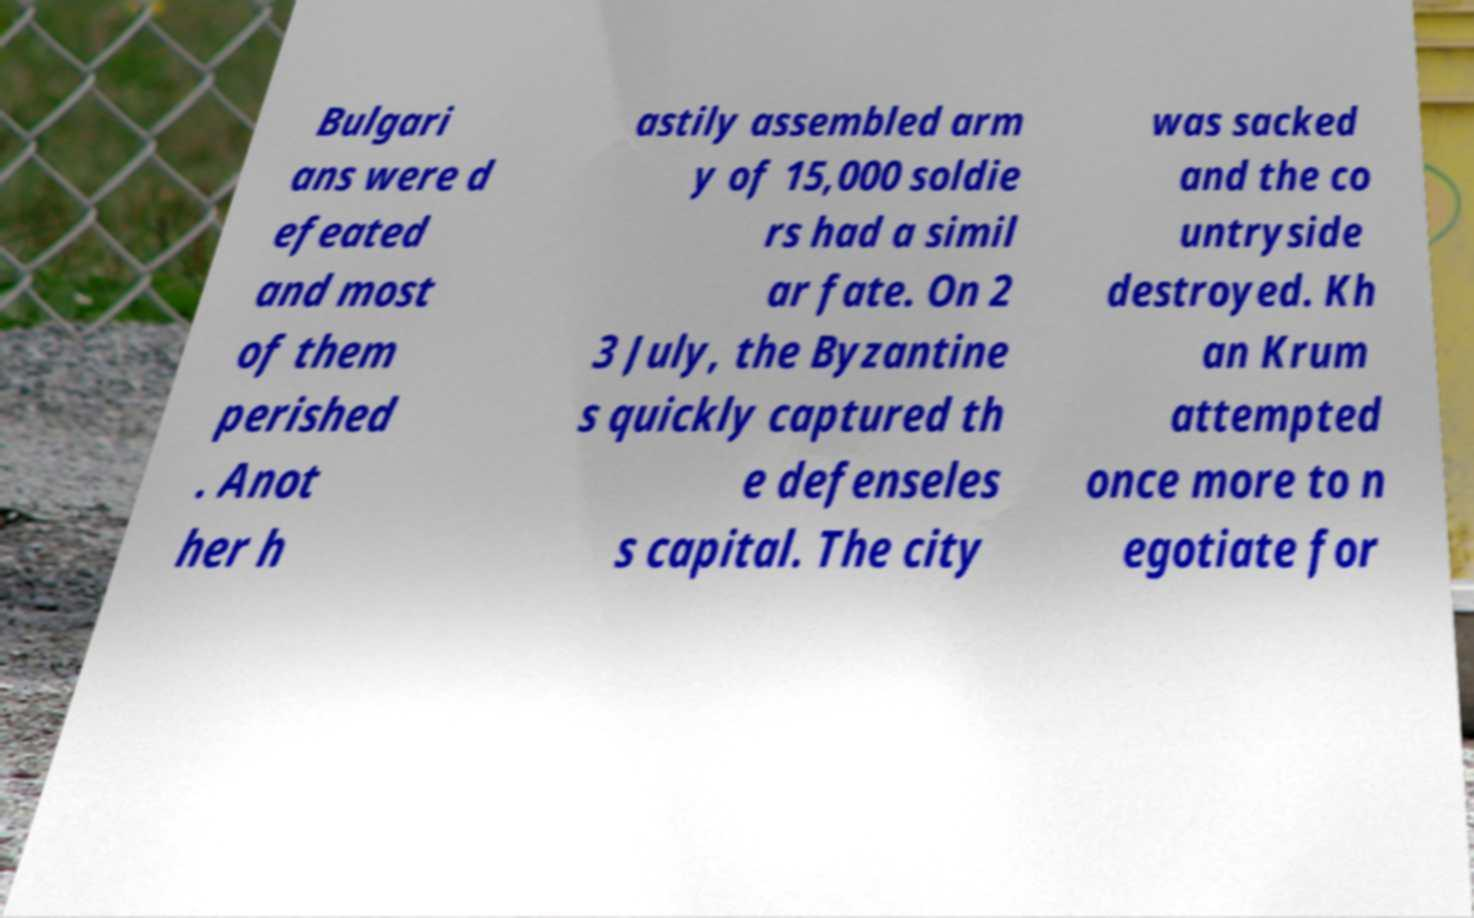Could you extract and type out the text from this image? Bulgari ans were d efeated and most of them perished . Anot her h astily assembled arm y of 15,000 soldie rs had a simil ar fate. On 2 3 July, the Byzantine s quickly captured th e defenseles s capital. The city was sacked and the co untryside destroyed. Kh an Krum attempted once more to n egotiate for 